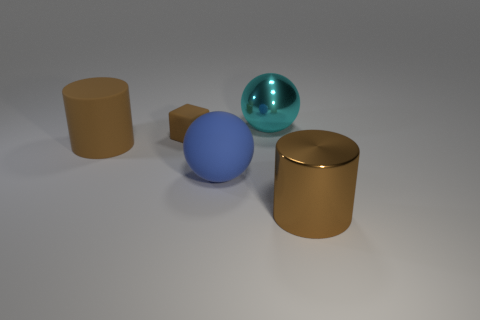How many small brown blocks are there?
Make the answer very short. 1. What number of things are either large blue rubber balls or cyan metal balls?
Provide a short and direct response. 2. What is the size of the other cylinder that is the same color as the large metal cylinder?
Provide a succinct answer. Large. Are there any small brown matte cubes in front of the large brown matte thing?
Your answer should be compact. No. Are there more big matte balls that are right of the big cyan ball than large brown things in front of the brown metal cylinder?
Provide a short and direct response. No. There is another object that is the same shape as the large brown matte thing; what size is it?
Your answer should be very brief. Large. How many cylinders are either cyan metallic things or large blue objects?
Offer a terse response. 0. What material is the big object that is the same color as the large rubber cylinder?
Your answer should be very brief. Metal. Is the number of matte cylinders that are on the right side of the large cyan shiny ball less than the number of small matte things that are to the right of the big blue ball?
Offer a terse response. No. How many things are big objects behind the big blue object or large brown metal blocks?
Your answer should be very brief. 2. 